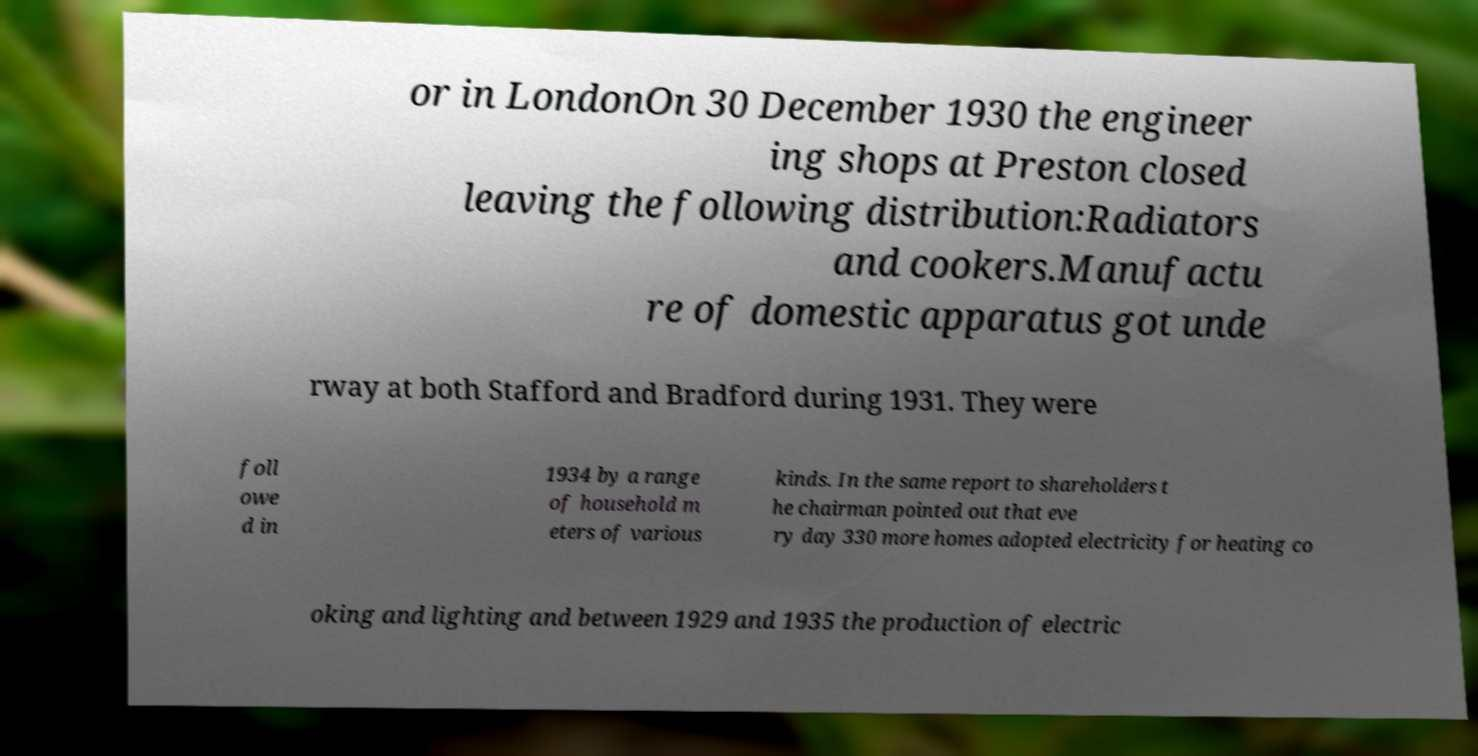Could you assist in decoding the text presented in this image and type it out clearly? or in LondonOn 30 December 1930 the engineer ing shops at Preston closed leaving the following distribution:Radiators and cookers.Manufactu re of domestic apparatus got unde rway at both Stafford and Bradford during 1931. They were foll owe d in 1934 by a range of household m eters of various kinds. In the same report to shareholders t he chairman pointed out that eve ry day 330 more homes adopted electricity for heating co oking and lighting and between 1929 and 1935 the production of electric 